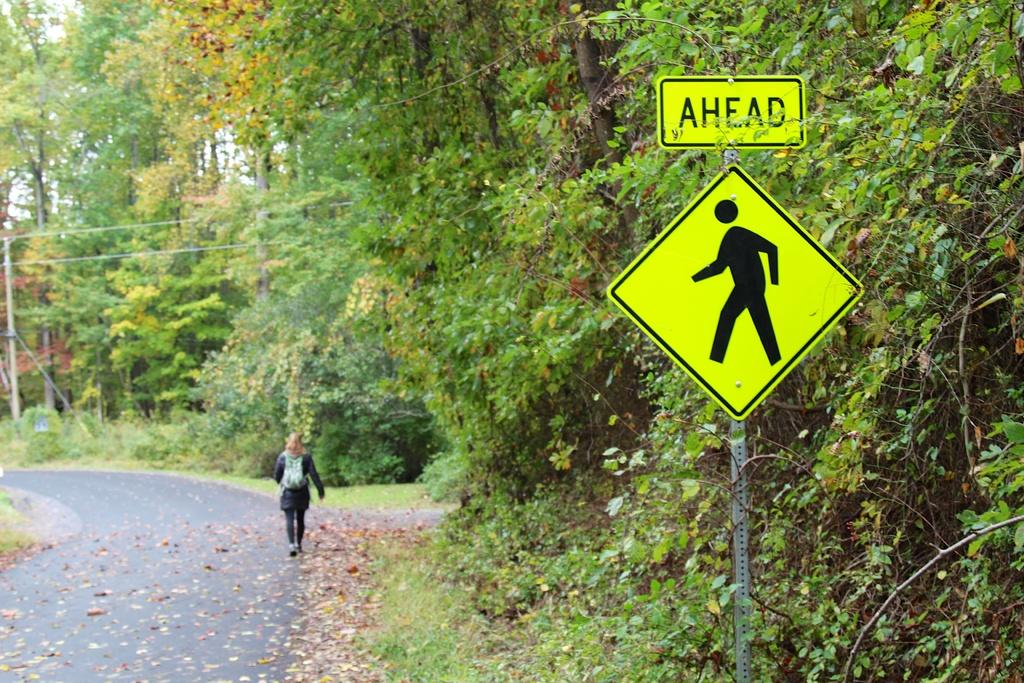<image>
Present a compact description of the photo's key features. A woman is walking on the verge of a country road. In the foreground is a yellow sign with the word Ahead and the silhouette of a person walking. 